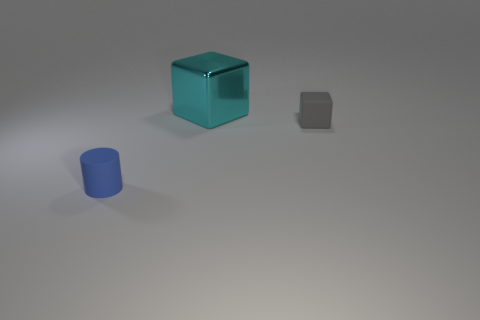Are there more big metal things in front of the large cyan block than small gray things?
Give a very brief answer. No. There is a thing that is on the right side of the small cylinder and on the left side of the small gray object; how big is it?
Keep it short and to the point. Large. What is the shape of the object that is both behind the small blue matte cylinder and left of the gray rubber cube?
Offer a very short reply. Cube. Is there a tiny matte object that is left of the object that is in front of the cube that is on the right side of the cyan metallic cube?
Provide a short and direct response. No. How many things are rubber objects that are left of the gray thing or objects on the right side of the blue rubber cylinder?
Your answer should be very brief. 3. Is the small thing behind the tiny cylinder made of the same material as the blue cylinder?
Your response must be concise. Yes. There is a object that is in front of the big metallic thing and right of the tiny blue cylinder; what material is it?
Ensure brevity in your answer.  Rubber. What color is the rubber thing that is behind the rubber object to the left of the small gray matte block?
Ensure brevity in your answer.  Gray. There is a small gray thing that is the same shape as the cyan metallic object; what is its material?
Offer a very short reply. Rubber. What color is the small matte thing that is left of the block on the left side of the tiny object that is to the right of the metallic cube?
Your response must be concise. Blue. 